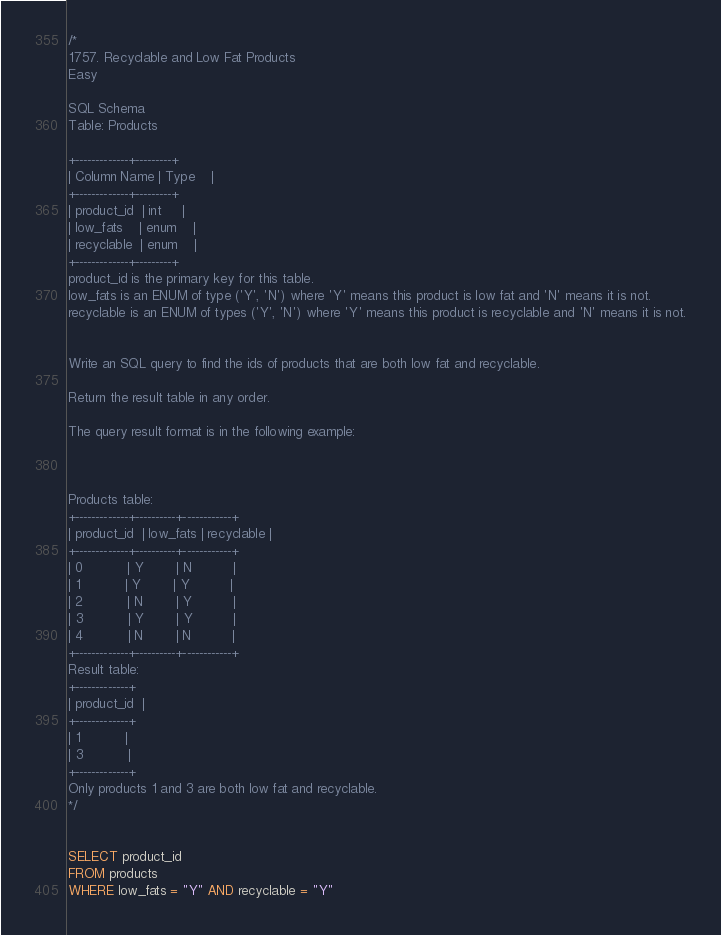Convert code to text. <code><loc_0><loc_0><loc_500><loc_500><_SQL_>/*
1757. Recyclable and Low Fat Products
Easy

SQL Schema
Table: Products

+-------------+---------+
| Column Name | Type    |
+-------------+---------+
| product_id  | int     |
| low_fats    | enum    |
| recyclable  | enum    |
+-------------+---------+
product_id is the primary key for this table.
low_fats is an ENUM of type ('Y', 'N') where 'Y' means this product is low fat and 'N' means it is not.
recyclable is an ENUM of types ('Y', 'N') where 'Y' means this product is recyclable and 'N' means it is not.
 

Write an SQL query to find the ids of products that are both low fat and recyclable.

Return the result table in any order.

The query result format is in the following example:

 

Products table:
+-------------+----------+------------+
| product_id  | low_fats | recyclable |
+-------------+----------+------------+
| 0           | Y        | N          |
| 1           | Y        | Y          |
| 2           | N        | Y          |
| 3           | Y        | Y          |
| 4           | N        | N          |
+-------------+----------+------------+
Result table:
+-------------+
| product_id  |
+-------------+
| 1           |
| 3           |
+-------------+
Only products 1 and 3 are both low fat and recyclable.
*/


SELECT product_id
FROM products
WHERE low_fats = "Y" AND recyclable = "Y"</code> 